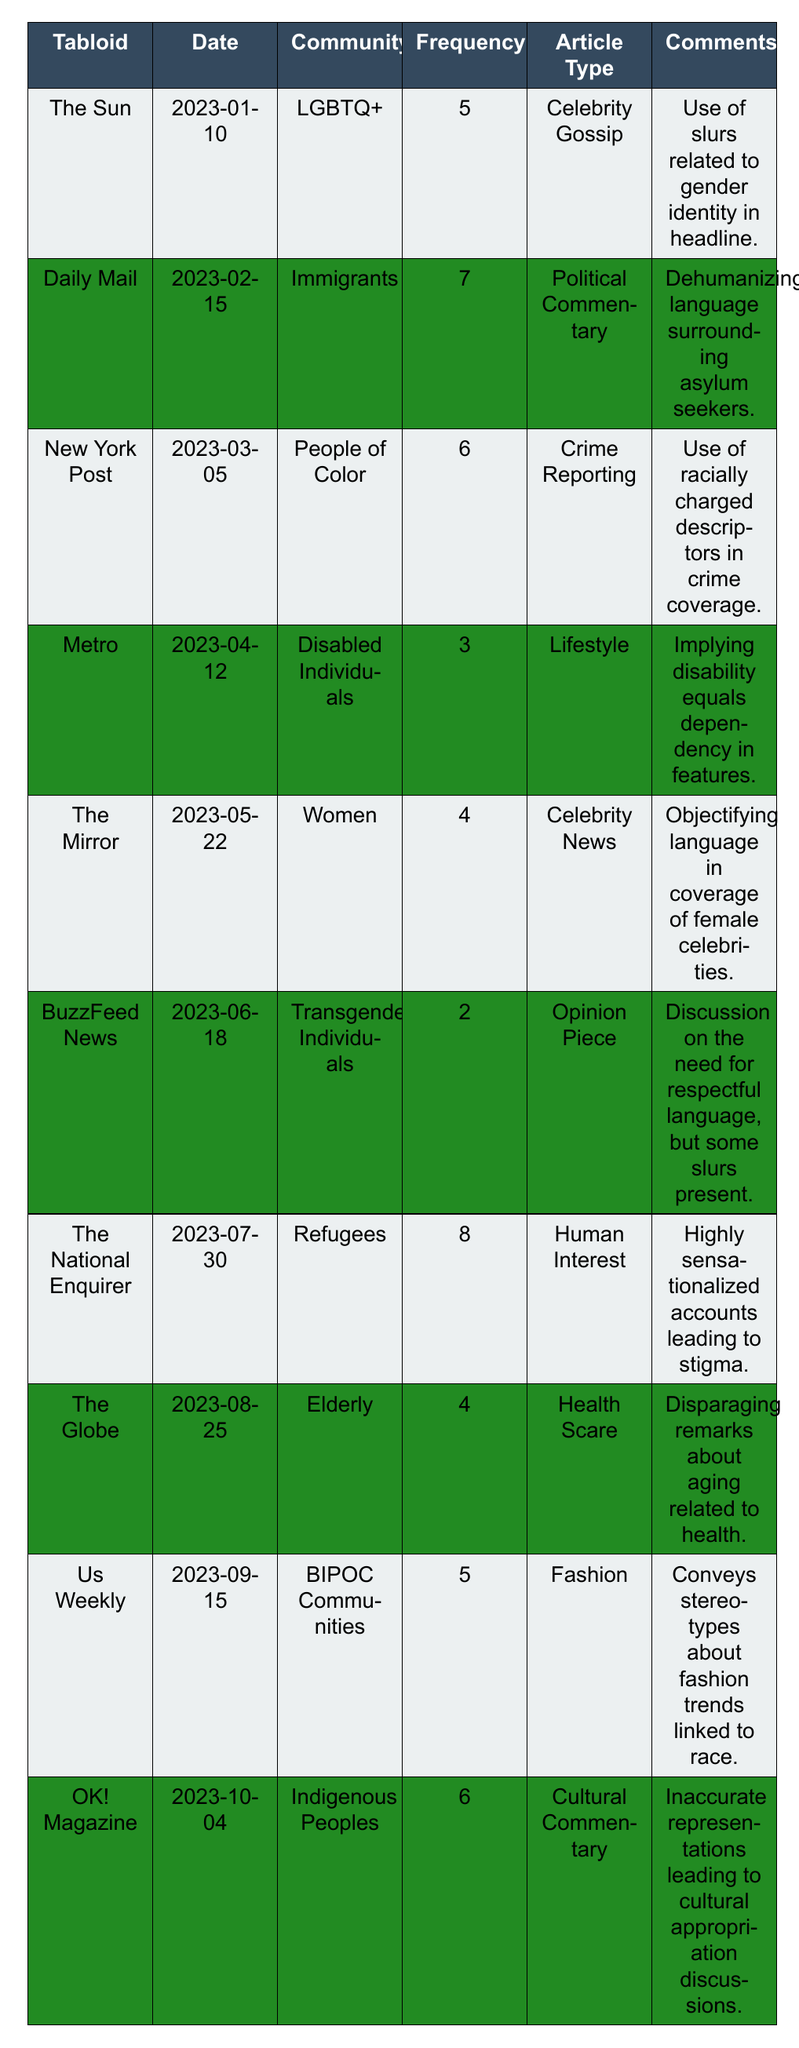What is the tabloid with the highest frequency of derogatory language? The table shows that 'The National Enquirer' has the highest frequency at 8.
Answer: The National Enquirer Which marginalized community is mentioned in the article with the lowest frequency of derogatory language? The table indicates 'Transgender Individuals' in BuzzFeed News, which has the lowest frequency at 2.
Answer: Transgender Individuals What is the average frequency of derogatory language across all tabloids? The frequencies are 5, 7, 6, 3, 4, 2, 8, 4, 5, and 6. Adding these up gives 50, and there are 10 tabloids, so the average is 50/10 = 5.
Answer: 5 Is derogatory language used more frequently when reporting on immigrants compared to disabled individuals? The frequency for immigrants is 7, while for disabled individuals it is 3. Thus, derogatory language is used more frequently for immigrants.
Answer: Yes How many tabloids have a derogatory language frequency of 5 or more? The tabloids with frequencies of 5 or more are The Sun, Daily Mail, New York Post, The National Enquirer, Us Weekly, and OK! Magazine, totaling 6.
Answer: 6 What types of articles are associated with derogatory language for BIPOC communities? The table lists 'Fashion' as the article type for BIPOC communities, which has a derogatory language frequency of 5.
Answer: Fashion Which type of article tends to use the most derogatory language based on the highest frequency? The 'Human Interest' article from The National Enquirer uses the most derogatory language with a frequency of 8.
Answer: Human Interest Can you identify any tabloids that used derogatory language against multiple marginalized communities? The table shows that each tabloid focuses on a distinct marginalized community, and no tabloids report on multiple communities, so the answer is no.
Answer: No How does the derogatory language frequency of tabloids focused on lifestyle compare to those focused on crime reporting? Metro focused on Lifestyle has a frequency of 3, while New York Post focused on Crime Reporting has a frequency of 6. Crime reporting has a higher frequency by 3.
Answer: Crime reporting has a higher frequency by 3 What derogatory terms were used in coverage of elderly individuals in tabloids? The table indicates disparaging remarks regarding aging and health in the article for elderly individuals in The Globe.
Answer: Disparaging remarks about aging related to health 